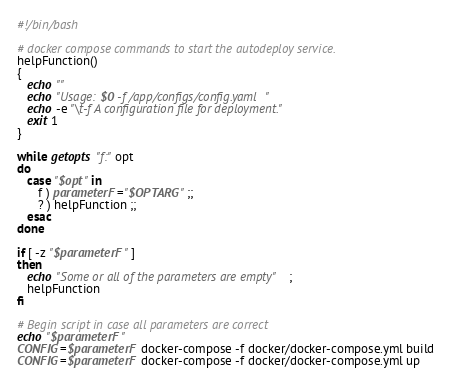<code> <loc_0><loc_0><loc_500><loc_500><_Bash_>#!/bin/bash

# docker compose commands to start the autodeploy service.
helpFunction()
{
   echo ""
   echo "Usage: $0 -f /app/configs/config.yaml"
   echo -e "\t-f A configuration file for deployment."
   exit 1 
}

while getopts "f:" opt
do
   case "$opt" in
      f ) parameterF="$OPTARG" ;;
      ? ) helpFunction ;; 
   esac
done

if [ -z "$parameterF" ]
then
   echo "Some or all of the parameters are empty";
   helpFunction
fi

# Begin script in case all parameters are correct
echo "$parameterF"
CONFIG=$parameterF docker-compose -f docker/docker-compose.yml build
CONFIG=$parameterF docker-compose -f docker/docker-compose.yml up
</code> 